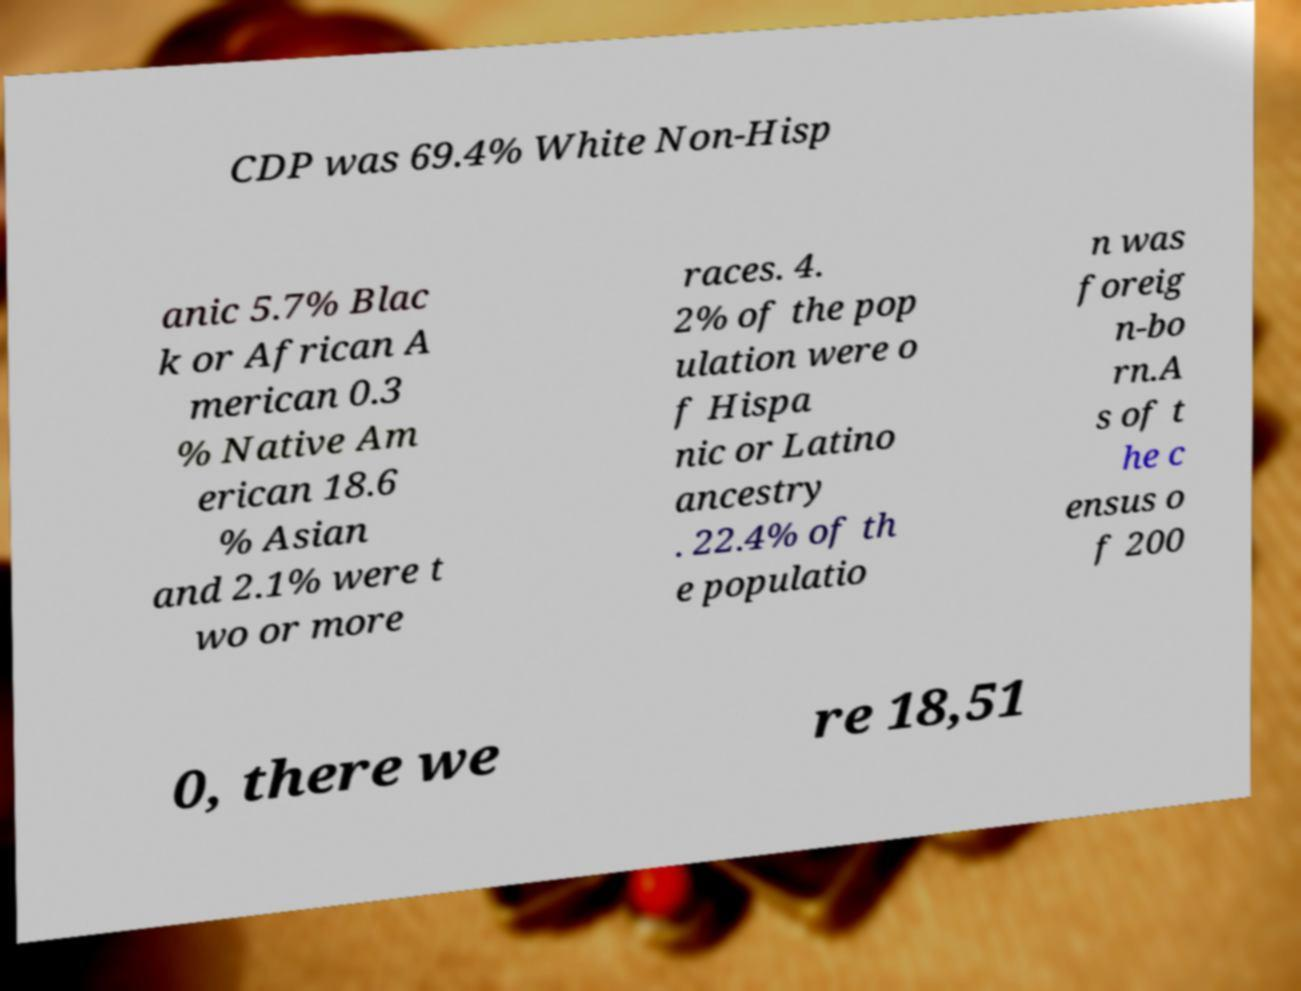There's text embedded in this image that I need extracted. Can you transcribe it verbatim? CDP was 69.4% White Non-Hisp anic 5.7% Blac k or African A merican 0.3 % Native Am erican 18.6 % Asian and 2.1% were t wo or more races. 4. 2% of the pop ulation were o f Hispa nic or Latino ancestry . 22.4% of th e populatio n was foreig n-bo rn.A s of t he c ensus o f 200 0, there we re 18,51 